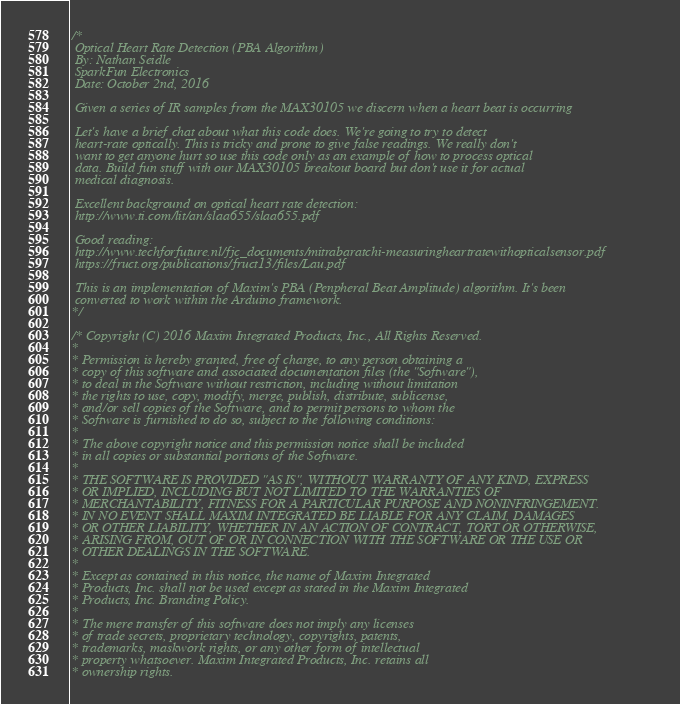Convert code to text. <code><loc_0><loc_0><loc_500><loc_500><_C_>/*
 Optical Heart Rate Detection (PBA Algorithm)
 By: Nathan Seidle
 SparkFun Electronics
 Date: October 2nd, 2016
 
 Given a series of IR samples from the MAX30105 we discern when a heart beat is occurring

 Let's have a brief chat about what this code does. We're going to try to detect
 heart-rate optically. This is tricky and prone to give false readings. We really don't
 want to get anyone hurt so use this code only as an example of how to process optical
 data. Build fun stuff with our MAX30105 breakout board but don't use it for actual
 medical diagnosis.

 Excellent background on optical heart rate detection:
 http://www.ti.com/lit/an/slaa655/slaa655.pdf

 Good reading:
 http://www.techforfuture.nl/fjc_documents/mitrabaratchi-measuringheartratewithopticalsensor.pdf
 https://fruct.org/publications/fruct13/files/Lau.pdf

 This is an implementation of Maxim's PBA (Penpheral Beat Amplitude) algorithm. It's been 
 converted to work within the Arduino framework.
*/

/* Copyright (C) 2016 Maxim Integrated Products, Inc., All Rights Reserved.
*
* Permission is hereby granted, free of charge, to any person obtaining a
* copy of this software and associated documentation files (the "Software"),
* to deal in the Software without restriction, including without limitation
* the rights to use, copy, modify, merge, publish, distribute, sublicense,
* and/or sell copies of the Software, and to permit persons to whom the
* Software is furnished to do so, subject to the following conditions:
*
* The above copyright notice and this permission notice shall be included
* in all copies or substantial portions of the Software.
*
* THE SOFTWARE IS PROVIDED "AS IS", WITHOUT WARRANTY OF ANY KIND, EXPRESS
* OR IMPLIED, INCLUDING BUT NOT LIMITED TO THE WARRANTIES OF
* MERCHANTABILITY, FITNESS FOR A PARTICULAR PURPOSE AND NONINFRINGEMENT.
* IN NO EVENT SHALL MAXIM INTEGRATED BE LIABLE FOR ANY CLAIM, DAMAGES
* OR OTHER LIABILITY, WHETHER IN AN ACTION OF CONTRACT, TORT OR OTHERWISE,
* ARISING FROM, OUT OF OR IN CONNECTION WITH THE SOFTWARE OR THE USE OR
* OTHER DEALINGS IN THE SOFTWARE.
*
* Except as contained in this notice, the name of Maxim Integrated
* Products, Inc. shall not be used except as stated in the Maxim Integrated
* Products, Inc. Branding Policy.
*
* The mere transfer of this software does not imply any licenses
* of trade secrets, proprietary technology, copyrights, patents,
* trademarks, maskwork rights, or any other form of intellectual
* property whatsoever. Maxim Integrated Products, Inc. retains all
* ownership rights.</code> 